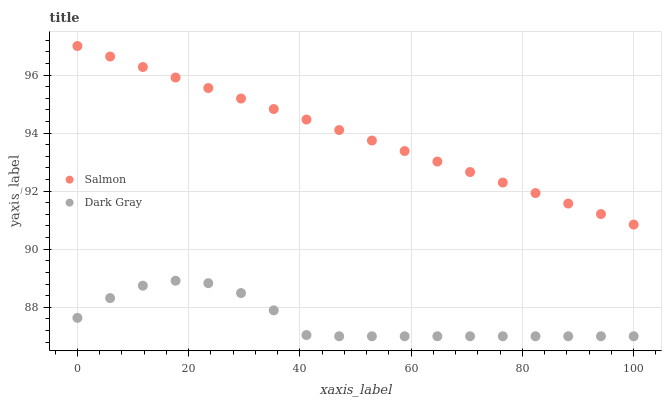Does Dark Gray have the minimum area under the curve?
Answer yes or no. Yes. Does Salmon have the maximum area under the curve?
Answer yes or no. Yes. Does Salmon have the minimum area under the curve?
Answer yes or no. No. Is Salmon the smoothest?
Answer yes or no. Yes. Is Dark Gray the roughest?
Answer yes or no. Yes. Is Salmon the roughest?
Answer yes or no. No. Does Dark Gray have the lowest value?
Answer yes or no. Yes. Does Salmon have the lowest value?
Answer yes or no. No. Does Salmon have the highest value?
Answer yes or no. Yes. Is Dark Gray less than Salmon?
Answer yes or no. Yes. Is Salmon greater than Dark Gray?
Answer yes or no. Yes. Does Dark Gray intersect Salmon?
Answer yes or no. No. 